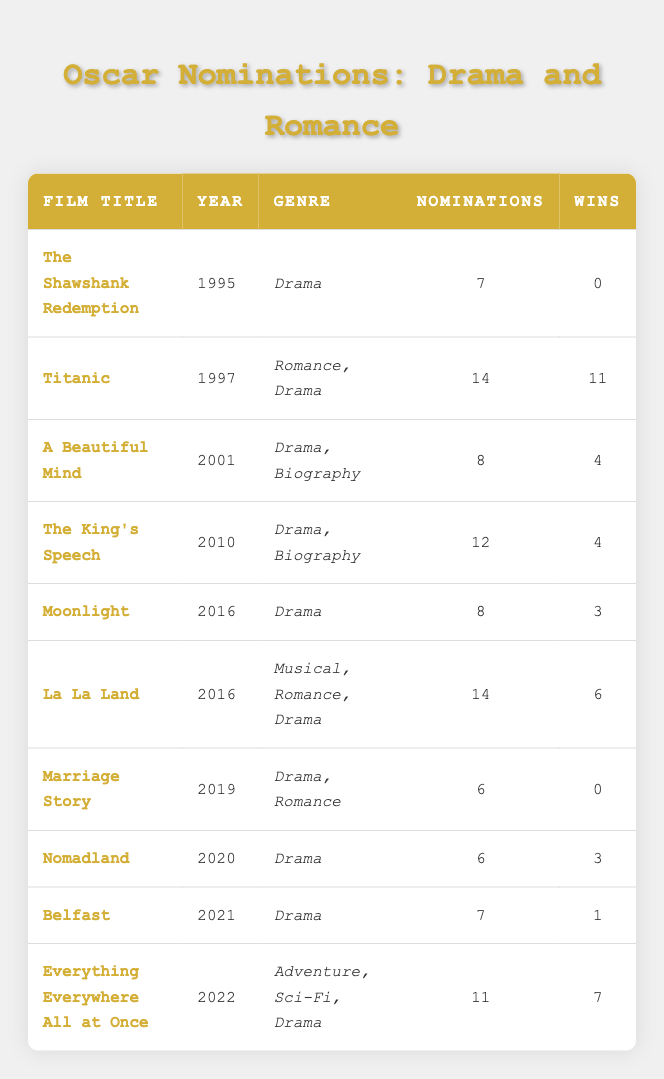What is the highest number of nominations received by a romantic film in this table? The romantic film with the highest nominations is "Titanic" with 14 nominations. I found this by scanning the genre column for romantic films and counting their nominations. Titanic had the most with 14.
Answer: 14 Which film won the most Oscars in this dataset? The film "Titanic" won the most Oscars, with a total of 11 wins. I identified this by looking at the wins column across all films and noting the maximum value, which is 11 for Titanic.
Answer: 11 How many films in this list have won at least one Oscar? Six films in the table have won at least one Oscar: Titanic, A Beautiful Mind, The King's Speech, La La Land, Nomadland, and Belfast. I counted the films that had a win greater than 0.
Answer: 6 What is the average number of nominations for the drama films in the list? To find the average, I first listed the drama films: "The Shawshank Redemption" (7), "A Beautiful Mind" (8), "The King's Speech" (12), "Moonlight" (8), "Nomadland" (6), "Belfast" (7), and "Everything Everywhere All at Once" (11). Adding these gives a total of 59 nominations. There are 7 drama films, so the average is 59/7, which equals approximately 8.43.
Answer: 8.43 Did "Marriage Story" receive more nominations than "Moonlight"? No, "Marriage Story" received 6 nominations while "Moonlight" received 8 nominations. To determine this, I compared the nominations for both films directly from the table.
Answer: No How many films contain the genre "Drama, Romance"? Only one film contains this genre: "Marriage Story" from 2019. I located this by checking the genre column specifically for the term "Drama, Romance."
Answer: 1 What is the total number of nominations for all the films in the dataset? The total number of nominations is 7 (Shawshank) + 14 (Titanic) + 8 (Beautiful Mind) + 12 (King's Speech) + 8 (Moonlight) + 14 (La La Land) + 6 (Marriage Story) + 6 (Nomadland) + 7 (Belfast) + 11 (Everything Everywhere). This sums to 98 nominations.
Answer: 98 Which year saw the release of the film with the least nominations in this table? "Marriage Story," released in 2019, had the least nominations at 6. I found this by listing the nominations for each film and identifying the lowest value.
Answer: 2019 